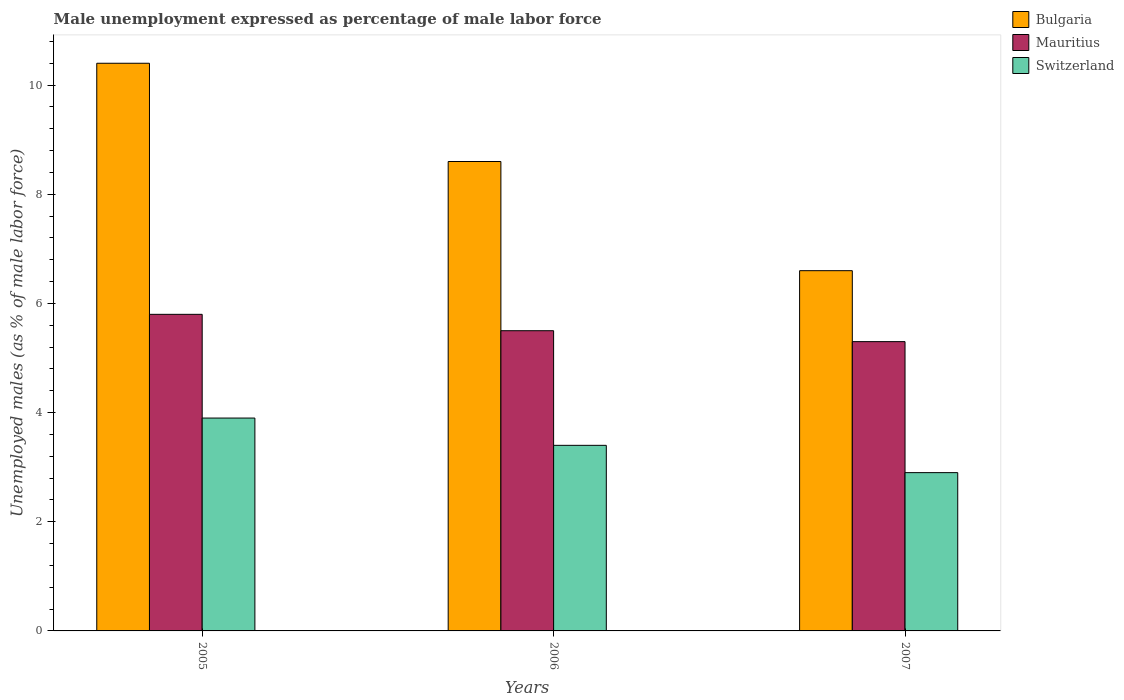How many bars are there on the 3rd tick from the left?
Give a very brief answer. 3. How many bars are there on the 1st tick from the right?
Offer a very short reply. 3. What is the label of the 2nd group of bars from the left?
Provide a succinct answer. 2006. Across all years, what is the maximum unemployment in males in in Bulgaria?
Offer a terse response. 10.4. Across all years, what is the minimum unemployment in males in in Switzerland?
Give a very brief answer. 2.9. What is the total unemployment in males in in Mauritius in the graph?
Offer a very short reply. 16.6. What is the difference between the unemployment in males in in Switzerland in 2006 and that in 2007?
Your response must be concise. 0.5. What is the difference between the unemployment in males in in Mauritius in 2007 and the unemployment in males in in Bulgaria in 2005?
Ensure brevity in your answer.  -5.1. What is the average unemployment in males in in Mauritius per year?
Give a very brief answer. 5.53. In the year 2005, what is the difference between the unemployment in males in in Mauritius and unemployment in males in in Switzerland?
Keep it short and to the point. 1.9. What is the ratio of the unemployment in males in in Switzerland in 2005 to that in 2006?
Provide a succinct answer. 1.15. Is the difference between the unemployment in males in in Mauritius in 2005 and 2007 greater than the difference between the unemployment in males in in Switzerland in 2005 and 2007?
Offer a very short reply. No. What is the difference between the highest and the second highest unemployment in males in in Bulgaria?
Keep it short and to the point. 1.8. What does the 3rd bar from the left in 2007 represents?
Give a very brief answer. Switzerland. What does the 1st bar from the right in 2007 represents?
Offer a terse response. Switzerland. Does the graph contain any zero values?
Provide a short and direct response. No. Where does the legend appear in the graph?
Your answer should be compact. Top right. What is the title of the graph?
Your response must be concise. Male unemployment expressed as percentage of male labor force. Does "North America" appear as one of the legend labels in the graph?
Give a very brief answer. No. What is the label or title of the Y-axis?
Make the answer very short. Unemployed males (as % of male labor force). What is the Unemployed males (as % of male labor force) of Bulgaria in 2005?
Offer a terse response. 10.4. What is the Unemployed males (as % of male labor force) in Mauritius in 2005?
Give a very brief answer. 5.8. What is the Unemployed males (as % of male labor force) of Switzerland in 2005?
Make the answer very short. 3.9. What is the Unemployed males (as % of male labor force) of Bulgaria in 2006?
Offer a terse response. 8.6. What is the Unemployed males (as % of male labor force) in Switzerland in 2006?
Give a very brief answer. 3.4. What is the Unemployed males (as % of male labor force) of Bulgaria in 2007?
Your answer should be compact. 6.6. What is the Unemployed males (as % of male labor force) in Mauritius in 2007?
Offer a very short reply. 5.3. What is the Unemployed males (as % of male labor force) of Switzerland in 2007?
Give a very brief answer. 2.9. Across all years, what is the maximum Unemployed males (as % of male labor force) in Bulgaria?
Provide a succinct answer. 10.4. Across all years, what is the maximum Unemployed males (as % of male labor force) of Mauritius?
Offer a very short reply. 5.8. Across all years, what is the maximum Unemployed males (as % of male labor force) in Switzerland?
Your response must be concise. 3.9. Across all years, what is the minimum Unemployed males (as % of male labor force) of Bulgaria?
Make the answer very short. 6.6. Across all years, what is the minimum Unemployed males (as % of male labor force) in Mauritius?
Offer a terse response. 5.3. Across all years, what is the minimum Unemployed males (as % of male labor force) in Switzerland?
Make the answer very short. 2.9. What is the total Unemployed males (as % of male labor force) of Bulgaria in the graph?
Make the answer very short. 25.6. What is the difference between the Unemployed males (as % of male labor force) in Bulgaria in 2005 and that in 2006?
Your answer should be very brief. 1.8. What is the difference between the Unemployed males (as % of male labor force) in Switzerland in 2005 and that in 2006?
Your response must be concise. 0.5. What is the difference between the Unemployed males (as % of male labor force) of Bulgaria in 2005 and that in 2007?
Make the answer very short. 3.8. What is the difference between the Unemployed males (as % of male labor force) of Switzerland in 2005 and that in 2007?
Your answer should be compact. 1. What is the difference between the Unemployed males (as % of male labor force) in Switzerland in 2006 and that in 2007?
Your answer should be very brief. 0.5. What is the difference between the Unemployed males (as % of male labor force) of Bulgaria in 2005 and the Unemployed males (as % of male labor force) of Mauritius in 2007?
Make the answer very short. 5.1. What is the difference between the Unemployed males (as % of male labor force) in Bulgaria in 2005 and the Unemployed males (as % of male labor force) in Switzerland in 2007?
Ensure brevity in your answer.  7.5. What is the difference between the Unemployed males (as % of male labor force) of Mauritius in 2006 and the Unemployed males (as % of male labor force) of Switzerland in 2007?
Make the answer very short. 2.6. What is the average Unemployed males (as % of male labor force) of Bulgaria per year?
Offer a terse response. 8.53. What is the average Unemployed males (as % of male labor force) in Mauritius per year?
Offer a terse response. 5.53. What is the average Unemployed males (as % of male labor force) of Switzerland per year?
Your answer should be very brief. 3.4. In the year 2007, what is the difference between the Unemployed males (as % of male labor force) in Bulgaria and Unemployed males (as % of male labor force) in Mauritius?
Ensure brevity in your answer.  1.3. What is the ratio of the Unemployed males (as % of male labor force) in Bulgaria in 2005 to that in 2006?
Offer a terse response. 1.21. What is the ratio of the Unemployed males (as % of male labor force) in Mauritius in 2005 to that in 2006?
Make the answer very short. 1.05. What is the ratio of the Unemployed males (as % of male labor force) in Switzerland in 2005 to that in 2006?
Provide a short and direct response. 1.15. What is the ratio of the Unemployed males (as % of male labor force) in Bulgaria in 2005 to that in 2007?
Ensure brevity in your answer.  1.58. What is the ratio of the Unemployed males (as % of male labor force) of Mauritius in 2005 to that in 2007?
Keep it short and to the point. 1.09. What is the ratio of the Unemployed males (as % of male labor force) of Switzerland in 2005 to that in 2007?
Offer a terse response. 1.34. What is the ratio of the Unemployed males (as % of male labor force) of Bulgaria in 2006 to that in 2007?
Provide a succinct answer. 1.3. What is the ratio of the Unemployed males (as % of male labor force) of Mauritius in 2006 to that in 2007?
Ensure brevity in your answer.  1.04. What is the ratio of the Unemployed males (as % of male labor force) of Switzerland in 2006 to that in 2007?
Keep it short and to the point. 1.17. What is the difference between the highest and the second highest Unemployed males (as % of male labor force) of Bulgaria?
Ensure brevity in your answer.  1.8. What is the difference between the highest and the second highest Unemployed males (as % of male labor force) in Mauritius?
Your answer should be very brief. 0.3. 